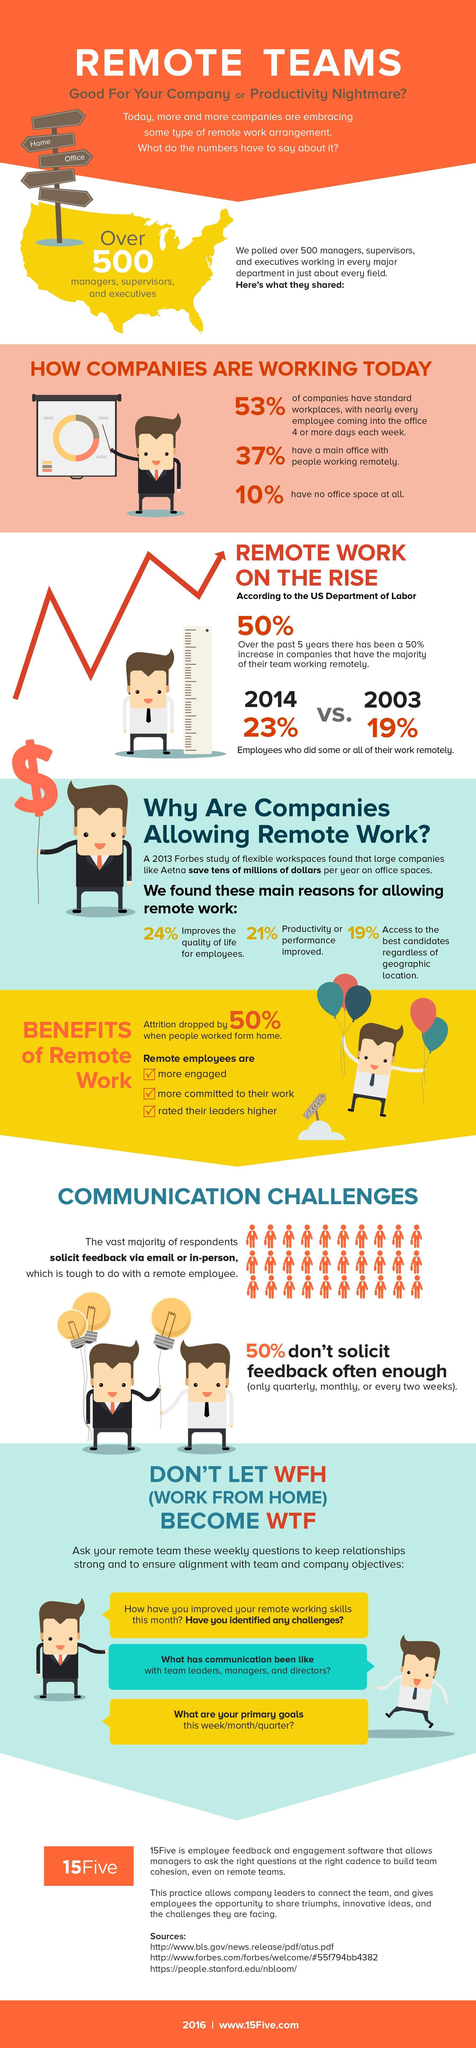What is the percentage increase in the quality of life for employees working remotely?
Answer the question with a short phrase. 24% What is the percentage increase in productivity or performance for employees working remotely? 21% According to the US Department of Labor, what percentage of employees did their work remotely in the year 2014? 23% According to the US Department of Labor, what percentage of employees did their work remotely in the year 2003? 19% 